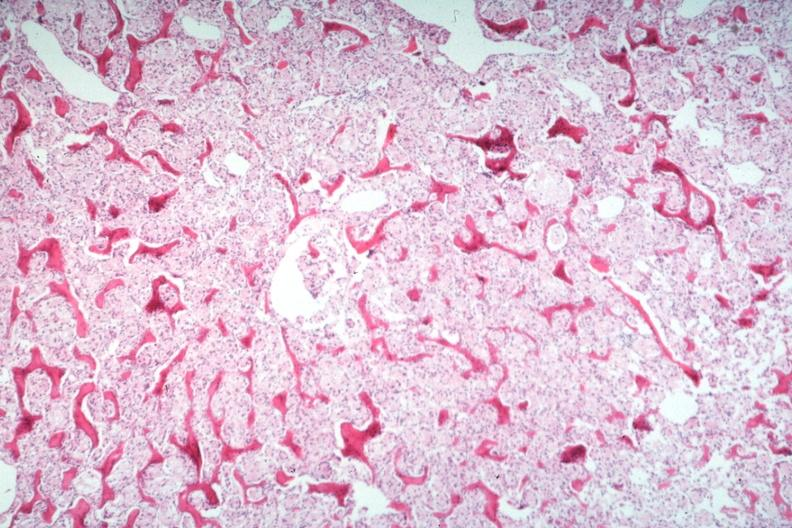s joints present?
Answer the question using a single word or phrase. Yes 